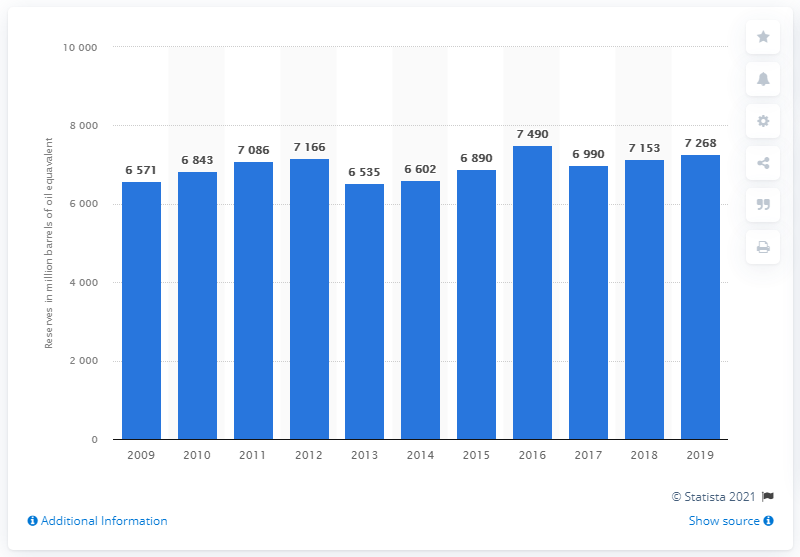Indicate a few pertinent items in this graphic. In 2019, Eni's average daily hydrocarbon reserves were approximately 72,680 barrels of oil equivalent. 